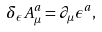Convert formula to latex. <formula><loc_0><loc_0><loc_500><loc_500>\delta _ { \epsilon } A ^ { a } _ { \mu } = \partial _ { \mu } \epsilon ^ { a } ,</formula> 